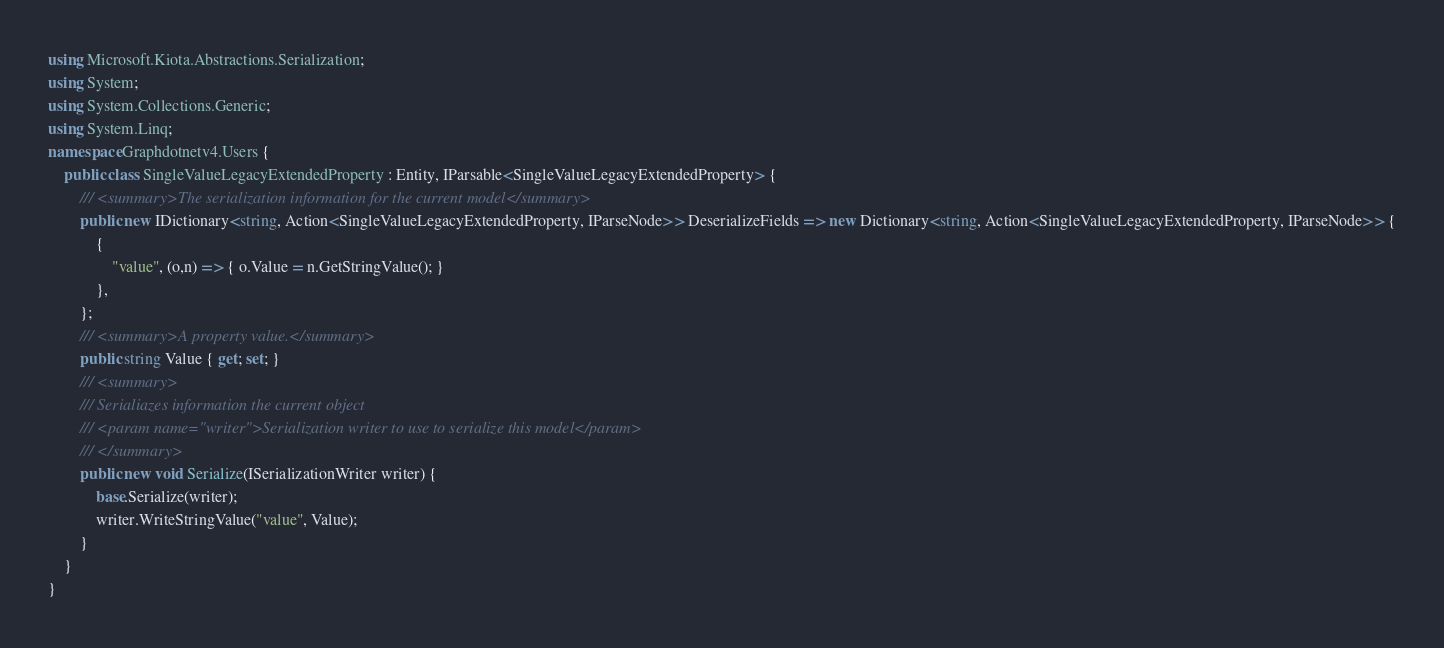<code> <loc_0><loc_0><loc_500><loc_500><_C#_>using Microsoft.Kiota.Abstractions.Serialization;
using System;
using System.Collections.Generic;
using System.Linq;
namespace Graphdotnetv4.Users {
    public class SingleValueLegacyExtendedProperty : Entity, IParsable<SingleValueLegacyExtendedProperty> {
        /// <summary>The serialization information for the current model</summary>
        public new IDictionary<string, Action<SingleValueLegacyExtendedProperty, IParseNode>> DeserializeFields => new Dictionary<string, Action<SingleValueLegacyExtendedProperty, IParseNode>> {
            {
                "value", (o,n) => { o.Value = n.GetStringValue(); }
            },
        };
        /// <summary>A property value.</summary>
        public string Value { get; set; }
        /// <summary>
        /// Serialiazes information the current object
        /// <param name="writer">Serialization writer to use to serialize this model</param>
        /// </summary>
        public new void Serialize(ISerializationWriter writer) {
            base.Serialize(writer);
            writer.WriteStringValue("value", Value);
        }
    }
}
</code> 